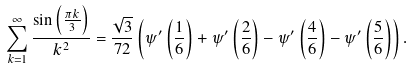<formula> <loc_0><loc_0><loc_500><loc_500>\sum _ { k = 1 } ^ { \infty } \frac { \sin \left ( \frac { \pi k } { 3 } \right ) } { k ^ { 2 } } = \frac { \sqrt { 3 } } { 7 2 } \left ( \psi ^ { \prime } \left ( \frac { 1 } { 6 } \right ) + \psi ^ { \prime } \left ( \frac { 2 } { 6 } \right ) - \psi ^ { \prime } \left ( \frac { 4 } { 6 } \right ) - \psi ^ { \prime } \left ( \frac { 5 } { 6 } \right ) \right ) .</formula> 